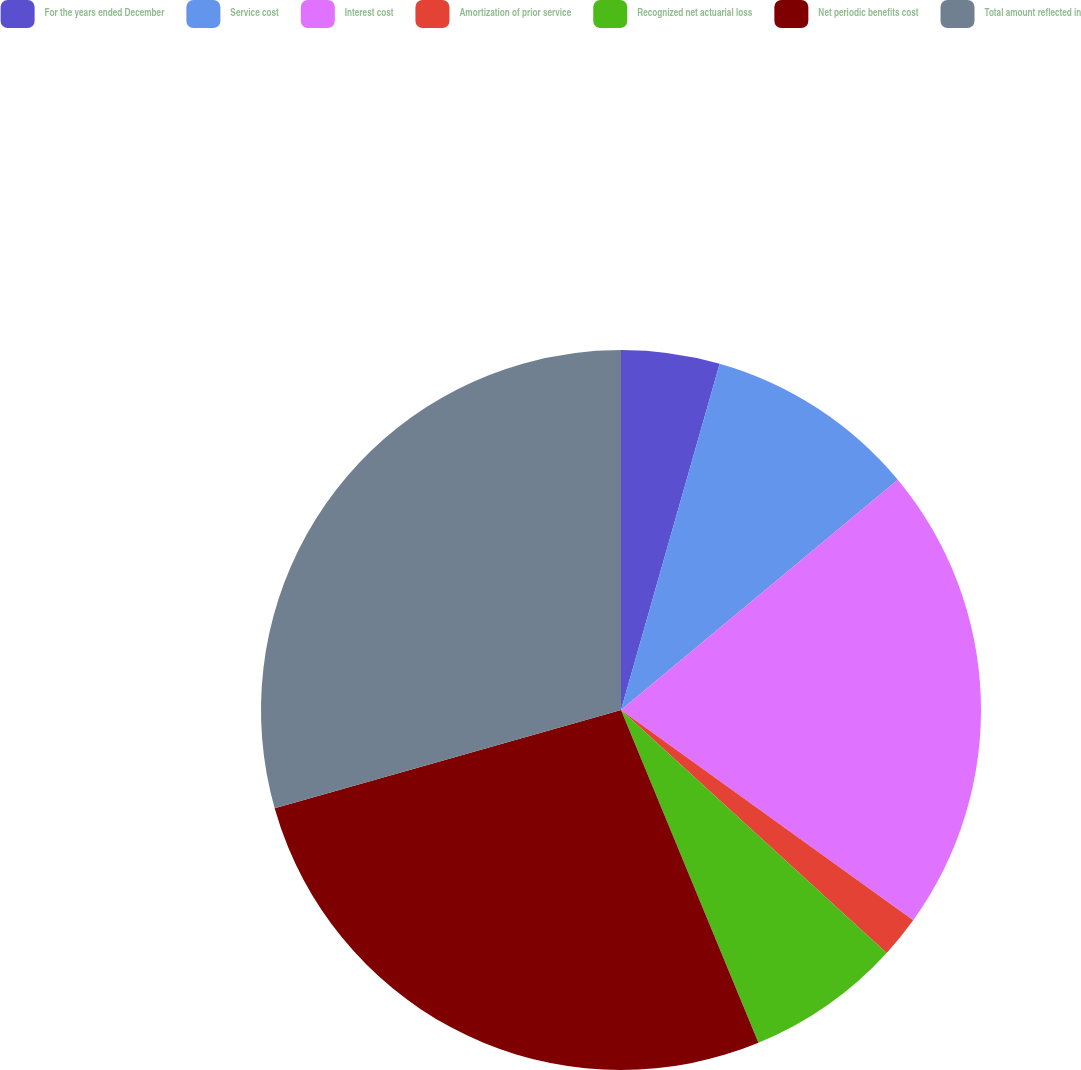Convert chart to OTSL. <chart><loc_0><loc_0><loc_500><loc_500><pie_chart><fcel>For the years ended December<fcel>Service cost<fcel>Interest cost<fcel>Amortization of prior service<fcel>Recognized net actuarial loss<fcel>Net periodic benefits cost<fcel>Total amount reflected in<nl><fcel>4.42%<fcel>9.54%<fcel>20.97%<fcel>1.86%<fcel>6.98%<fcel>26.84%<fcel>29.4%<nl></chart> 